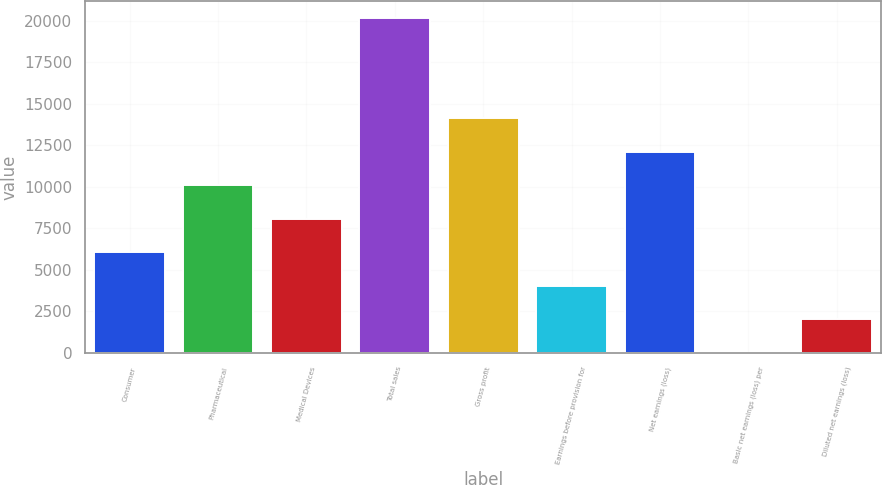Convert chart. <chart><loc_0><loc_0><loc_500><loc_500><bar_chart><fcel>Consumer<fcel>Pharmaceutical<fcel>Medical Devices<fcel>Total sales<fcel>Gross profit<fcel>Earnings before provision for<fcel>Net earnings (loss)<fcel>Basic net earnings (loss) per<fcel>Diluted net earnings (loss)<nl><fcel>6061.29<fcel>10099.5<fcel>8080.39<fcel>20195<fcel>14137.7<fcel>4042.19<fcel>12118.6<fcel>3.99<fcel>2023.09<nl></chart> 